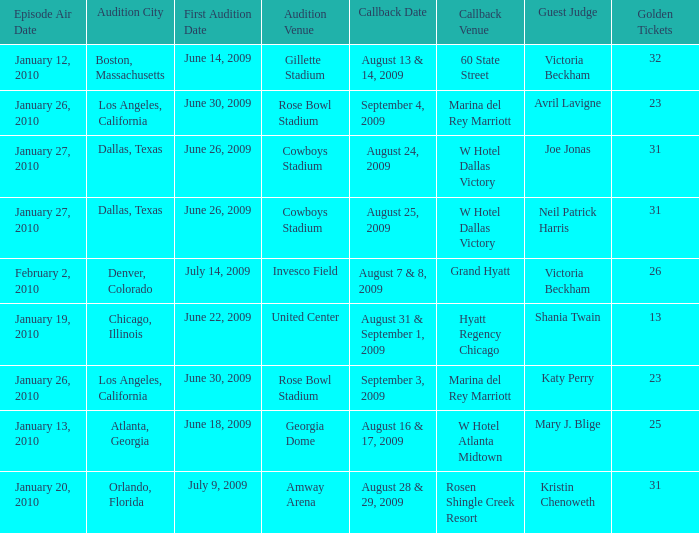Name the golden ticket for invesco field 26.0. 